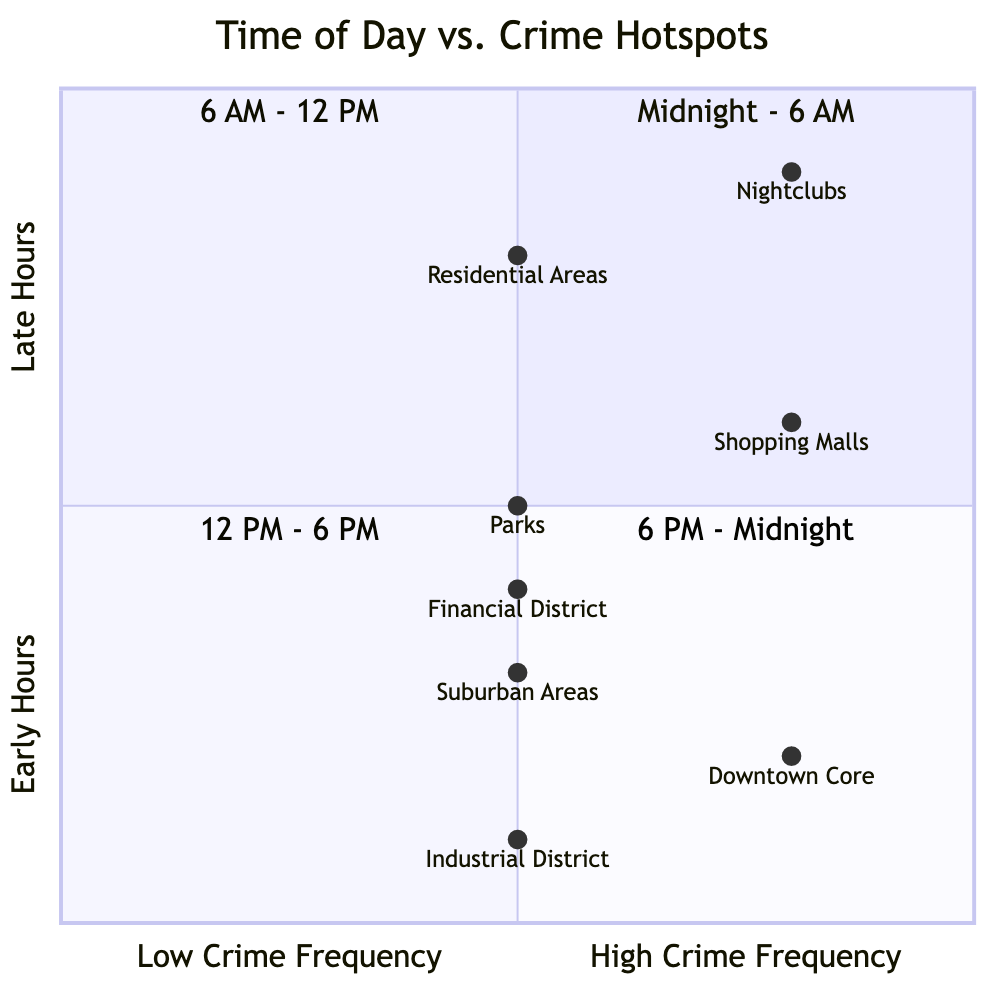What are the two crime types in the Downtown Core? The Downtown Core has two listed crime types: Assault and Robbery, as indicated in the corresponding quadrant of the chart.
Answer: Assault, Robbery Which quadrant lists the highest frequency of crime? The "6 PM - Midnight" quadrant lists the highest frequency of crime, specifically in locations like Nightclubs where the frequency is described as "High".
Answer: 6 PM - Midnight How many locations are identified in the "12 PM - 6 PM" quadrant? This quadrant identifies two locations: Shopping Malls and Parks. The count of locations can be directly observed in the details of that particular quadrant.
Answer: 2 What is the optimal patrol time for the Industrial District? The optimal patrol time for the Industrial District, which is listed in the "Midnight - 6 AM" quadrant, is from 12:00 AM to 6:00 AM. This can be found under the location details in that quadrant.
Answer: 12:00 AM - 6:00 AM Which area is associated with drug-related crimes during the afternoon? The Parks are associated with drug-related crimes, specifically drug dealing, during the afternoon hours. This is clearly mentioned under the "12 PM - 6 PM" quadrant.
Answer: Parks What frequency of crime is reported in the Financial District? The Financial District has a medium frequency of crime, which is clearly stated in the data for that area within the "6 AM - 12 PM" quadrant.
Answer: Medium Which crime type is most frequently associated with Nightclubs? Assault is the most frequently associated crime type with Nightclubs, as indicated in the "6 PM - Midnight" quadrant description.
Answer: Assault In which quadrant do we see the location with the highest frequency of Shoplifting? The Shopping Malls located in the "12 PM - 6 PM" quadrant report a high frequency of Shoplifting, as specified in the crime type details for that area.
Answer: 12 PM - 6 PM 